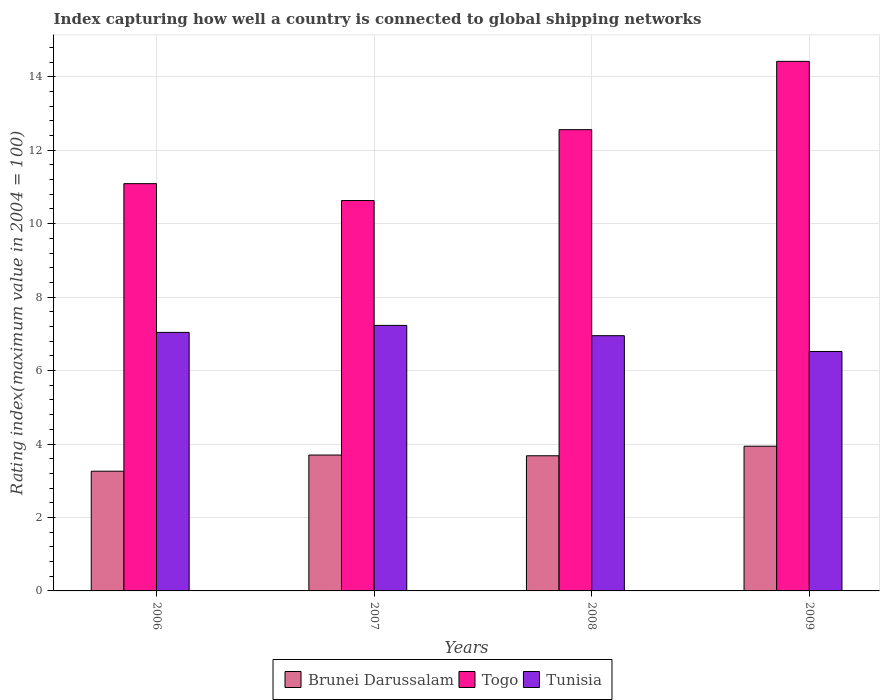How many different coloured bars are there?
Offer a terse response. 3. How many groups of bars are there?
Make the answer very short. 4. Are the number of bars per tick equal to the number of legend labels?
Give a very brief answer. Yes. Are the number of bars on each tick of the X-axis equal?
Give a very brief answer. Yes. What is the label of the 3rd group of bars from the left?
Provide a succinct answer. 2008. What is the rating index in Brunei Darussalam in 2006?
Offer a very short reply. 3.26. Across all years, what is the maximum rating index in Togo?
Ensure brevity in your answer.  14.42. Across all years, what is the minimum rating index in Tunisia?
Your response must be concise. 6.52. In which year was the rating index in Tunisia maximum?
Provide a short and direct response. 2007. In which year was the rating index in Tunisia minimum?
Provide a succinct answer. 2009. What is the total rating index in Tunisia in the graph?
Provide a short and direct response. 27.74. What is the difference between the rating index in Brunei Darussalam in 2008 and that in 2009?
Offer a terse response. -0.26. What is the difference between the rating index in Brunei Darussalam in 2008 and the rating index in Togo in 2007?
Provide a short and direct response. -6.95. What is the average rating index in Brunei Darussalam per year?
Ensure brevity in your answer.  3.65. In the year 2009, what is the difference between the rating index in Brunei Darussalam and rating index in Tunisia?
Offer a very short reply. -2.58. What is the ratio of the rating index in Tunisia in 2007 to that in 2008?
Offer a terse response. 1.04. Is the difference between the rating index in Brunei Darussalam in 2007 and 2009 greater than the difference between the rating index in Tunisia in 2007 and 2009?
Offer a very short reply. No. What is the difference between the highest and the second highest rating index in Tunisia?
Your response must be concise. 0.19. What is the difference between the highest and the lowest rating index in Tunisia?
Your answer should be compact. 0.71. In how many years, is the rating index in Brunei Darussalam greater than the average rating index in Brunei Darussalam taken over all years?
Give a very brief answer. 3. What does the 1st bar from the left in 2008 represents?
Provide a short and direct response. Brunei Darussalam. What does the 3rd bar from the right in 2008 represents?
Your response must be concise. Brunei Darussalam. Are all the bars in the graph horizontal?
Give a very brief answer. No. How many years are there in the graph?
Give a very brief answer. 4. What is the difference between two consecutive major ticks on the Y-axis?
Keep it short and to the point. 2. Are the values on the major ticks of Y-axis written in scientific E-notation?
Provide a succinct answer. No. Does the graph contain any zero values?
Provide a succinct answer. No. Does the graph contain grids?
Provide a short and direct response. Yes. Where does the legend appear in the graph?
Keep it short and to the point. Bottom center. How many legend labels are there?
Provide a short and direct response. 3. What is the title of the graph?
Provide a short and direct response. Index capturing how well a country is connected to global shipping networks. Does "Nigeria" appear as one of the legend labels in the graph?
Offer a very short reply. No. What is the label or title of the X-axis?
Your answer should be compact. Years. What is the label or title of the Y-axis?
Keep it short and to the point. Rating index(maximum value in 2004 = 100). What is the Rating index(maximum value in 2004 = 100) in Brunei Darussalam in 2006?
Make the answer very short. 3.26. What is the Rating index(maximum value in 2004 = 100) in Togo in 2006?
Keep it short and to the point. 11.09. What is the Rating index(maximum value in 2004 = 100) of Tunisia in 2006?
Offer a terse response. 7.04. What is the Rating index(maximum value in 2004 = 100) in Brunei Darussalam in 2007?
Your answer should be very brief. 3.7. What is the Rating index(maximum value in 2004 = 100) of Togo in 2007?
Offer a very short reply. 10.63. What is the Rating index(maximum value in 2004 = 100) in Tunisia in 2007?
Your response must be concise. 7.23. What is the Rating index(maximum value in 2004 = 100) of Brunei Darussalam in 2008?
Ensure brevity in your answer.  3.68. What is the Rating index(maximum value in 2004 = 100) in Togo in 2008?
Offer a very short reply. 12.56. What is the Rating index(maximum value in 2004 = 100) in Tunisia in 2008?
Provide a short and direct response. 6.95. What is the Rating index(maximum value in 2004 = 100) of Brunei Darussalam in 2009?
Make the answer very short. 3.94. What is the Rating index(maximum value in 2004 = 100) of Togo in 2009?
Offer a terse response. 14.42. What is the Rating index(maximum value in 2004 = 100) in Tunisia in 2009?
Give a very brief answer. 6.52. Across all years, what is the maximum Rating index(maximum value in 2004 = 100) in Brunei Darussalam?
Keep it short and to the point. 3.94. Across all years, what is the maximum Rating index(maximum value in 2004 = 100) of Togo?
Give a very brief answer. 14.42. Across all years, what is the maximum Rating index(maximum value in 2004 = 100) of Tunisia?
Keep it short and to the point. 7.23. Across all years, what is the minimum Rating index(maximum value in 2004 = 100) of Brunei Darussalam?
Provide a short and direct response. 3.26. Across all years, what is the minimum Rating index(maximum value in 2004 = 100) of Togo?
Make the answer very short. 10.63. Across all years, what is the minimum Rating index(maximum value in 2004 = 100) in Tunisia?
Make the answer very short. 6.52. What is the total Rating index(maximum value in 2004 = 100) in Brunei Darussalam in the graph?
Keep it short and to the point. 14.58. What is the total Rating index(maximum value in 2004 = 100) in Togo in the graph?
Offer a very short reply. 48.7. What is the total Rating index(maximum value in 2004 = 100) of Tunisia in the graph?
Give a very brief answer. 27.74. What is the difference between the Rating index(maximum value in 2004 = 100) in Brunei Darussalam in 2006 and that in 2007?
Offer a terse response. -0.44. What is the difference between the Rating index(maximum value in 2004 = 100) of Togo in 2006 and that in 2007?
Your answer should be very brief. 0.46. What is the difference between the Rating index(maximum value in 2004 = 100) of Tunisia in 2006 and that in 2007?
Provide a short and direct response. -0.19. What is the difference between the Rating index(maximum value in 2004 = 100) in Brunei Darussalam in 2006 and that in 2008?
Your response must be concise. -0.42. What is the difference between the Rating index(maximum value in 2004 = 100) in Togo in 2006 and that in 2008?
Your answer should be very brief. -1.47. What is the difference between the Rating index(maximum value in 2004 = 100) of Tunisia in 2006 and that in 2008?
Provide a succinct answer. 0.09. What is the difference between the Rating index(maximum value in 2004 = 100) in Brunei Darussalam in 2006 and that in 2009?
Provide a short and direct response. -0.68. What is the difference between the Rating index(maximum value in 2004 = 100) of Togo in 2006 and that in 2009?
Your answer should be very brief. -3.33. What is the difference between the Rating index(maximum value in 2004 = 100) in Tunisia in 2006 and that in 2009?
Offer a very short reply. 0.52. What is the difference between the Rating index(maximum value in 2004 = 100) in Brunei Darussalam in 2007 and that in 2008?
Provide a short and direct response. 0.02. What is the difference between the Rating index(maximum value in 2004 = 100) of Togo in 2007 and that in 2008?
Provide a short and direct response. -1.93. What is the difference between the Rating index(maximum value in 2004 = 100) of Tunisia in 2007 and that in 2008?
Offer a very short reply. 0.28. What is the difference between the Rating index(maximum value in 2004 = 100) of Brunei Darussalam in 2007 and that in 2009?
Give a very brief answer. -0.24. What is the difference between the Rating index(maximum value in 2004 = 100) of Togo in 2007 and that in 2009?
Provide a succinct answer. -3.79. What is the difference between the Rating index(maximum value in 2004 = 100) of Tunisia in 2007 and that in 2009?
Provide a short and direct response. 0.71. What is the difference between the Rating index(maximum value in 2004 = 100) in Brunei Darussalam in 2008 and that in 2009?
Ensure brevity in your answer.  -0.26. What is the difference between the Rating index(maximum value in 2004 = 100) of Togo in 2008 and that in 2009?
Your answer should be compact. -1.86. What is the difference between the Rating index(maximum value in 2004 = 100) in Tunisia in 2008 and that in 2009?
Make the answer very short. 0.43. What is the difference between the Rating index(maximum value in 2004 = 100) in Brunei Darussalam in 2006 and the Rating index(maximum value in 2004 = 100) in Togo in 2007?
Your answer should be compact. -7.37. What is the difference between the Rating index(maximum value in 2004 = 100) of Brunei Darussalam in 2006 and the Rating index(maximum value in 2004 = 100) of Tunisia in 2007?
Keep it short and to the point. -3.97. What is the difference between the Rating index(maximum value in 2004 = 100) of Togo in 2006 and the Rating index(maximum value in 2004 = 100) of Tunisia in 2007?
Provide a succinct answer. 3.86. What is the difference between the Rating index(maximum value in 2004 = 100) in Brunei Darussalam in 2006 and the Rating index(maximum value in 2004 = 100) in Togo in 2008?
Your answer should be very brief. -9.3. What is the difference between the Rating index(maximum value in 2004 = 100) in Brunei Darussalam in 2006 and the Rating index(maximum value in 2004 = 100) in Tunisia in 2008?
Provide a succinct answer. -3.69. What is the difference between the Rating index(maximum value in 2004 = 100) in Togo in 2006 and the Rating index(maximum value in 2004 = 100) in Tunisia in 2008?
Your answer should be compact. 4.14. What is the difference between the Rating index(maximum value in 2004 = 100) of Brunei Darussalam in 2006 and the Rating index(maximum value in 2004 = 100) of Togo in 2009?
Keep it short and to the point. -11.16. What is the difference between the Rating index(maximum value in 2004 = 100) of Brunei Darussalam in 2006 and the Rating index(maximum value in 2004 = 100) of Tunisia in 2009?
Provide a succinct answer. -3.26. What is the difference between the Rating index(maximum value in 2004 = 100) of Togo in 2006 and the Rating index(maximum value in 2004 = 100) of Tunisia in 2009?
Provide a short and direct response. 4.57. What is the difference between the Rating index(maximum value in 2004 = 100) in Brunei Darussalam in 2007 and the Rating index(maximum value in 2004 = 100) in Togo in 2008?
Your response must be concise. -8.86. What is the difference between the Rating index(maximum value in 2004 = 100) in Brunei Darussalam in 2007 and the Rating index(maximum value in 2004 = 100) in Tunisia in 2008?
Offer a terse response. -3.25. What is the difference between the Rating index(maximum value in 2004 = 100) of Togo in 2007 and the Rating index(maximum value in 2004 = 100) of Tunisia in 2008?
Your answer should be very brief. 3.68. What is the difference between the Rating index(maximum value in 2004 = 100) in Brunei Darussalam in 2007 and the Rating index(maximum value in 2004 = 100) in Togo in 2009?
Ensure brevity in your answer.  -10.72. What is the difference between the Rating index(maximum value in 2004 = 100) in Brunei Darussalam in 2007 and the Rating index(maximum value in 2004 = 100) in Tunisia in 2009?
Keep it short and to the point. -2.82. What is the difference between the Rating index(maximum value in 2004 = 100) of Togo in 2007 and the Rating index(maximum value in 2004 = 100) of Tunisia in 2009?
Give a very brief answer. 4.11. What is the difference between the Rating index(maximum value in 2004 = 100) in Brunei Darussalam in 2008 and the Rating index(maximum value in 2004 = 100) in Togo in 2009?
Provide a succinct answer. -10.74. What is the difference between the Rating index(maximum value in 2004 = 100) in Brunei Darussalam in 2008 and the Rating index(maximum value in 2004 = 100) in Tunisia in 2009?
Offer a very short reply. -2.84. What is the difference between the Rating index(maximum value in 2004 = 100) in Togo in 2008 and the Rating index(maximum value in 2004 = 100) in Tunisia in 2009?
Your answer should be compact. 6.04. What is the average Rating index(maximum value in 2004 = 100) in Brunei Darussalam per year?
Give a very brief answer. 3.65. What is the average Rating index(maximum value in 2004 = 100) of Togo per year?
Give a very brief answer. 12.18. What is the average Rating index(maximum value in 2004 = 100) in Tunisia per year?
Provide a succinct answer. 6.93. In the year 2006, what is the difference between the Rating index(maximum value in 2004 = 100) of Brunei Darussalam and Rating index(maximum value in 2004 = 100) of Togo?
Your response must be concise. -7.83. In the year 2006, what is the difference between the Rating index(maximum value in 2004 = 100) of Brunei Darussalam and Rating index(maximum value in 2004 = 100) of Tunisia?
Your answer should be very brief. -3.78. In the year 2006, what is the difference between the Rating index(maximum value in 2004 = 100) of Togo and Rating index(maximum value in 2004 = 100) of Tunisia?
Your response must be concise. 4.05. In the year 2007, what is the difference between the Rating index(maximum value in 2004 = 100) in Brunei Darussalam and Rating index(maximum value in 2004 = 100) in Togo?
Offer a very short reply. -6.93. In the year 2007, what is the difference between the Rating index(maximum value in 2004 = 100) in Brunei Darussalam and Rating index(maximum value in 2004 = 100) in Tunisia?
Offer a very short reply. -3.53. In the year 2007, what is the difference between the Rating index(maximum value in 2004 = 100) of Togo and Rating index(maximum value in 2004 = 100) of Tunisia?
Offer a very short reply. 3.4. In the year 2008, what is the difference between the Rating index(maximum value in 2004 = 100) of Brunei Darussalam and Rating index(maximum value in 2004 = 100) of Togo?
Provide a short and direct response. -8.88. In the year 2008, what is the difference between the Rating index(maximum value in 2004 = 100) in Brunei Darussalam and Rating index(maximum value in 2004 = 100) in Tunisia?
Make the answer very short. -3.27. In the year 2008, what is the difference between the Rating index(maximum value in 2004 = 100) in Togo and Rating index(maximum value in 2004 = 100) in Tunisia?
Your answer should be compact. 5.61. In the year 2009, what is the difference between the Rating index(maximum value in 2004 = 100) of Brunei Darussalam and Rating index(maximum value in 2004 = 100) of Togo?
Ensure brevity in your answer.  -10.48. In the year 2009, what is the difference between the Rating index(maximum value in 2004 = 100) in Brunei Darussalam and Rating index(maximum value in 2004 = 100) in Tunisia?
Provide a short and direct response. -2.58. What is the ratio of the Rating index(maximum value in 2004 = 100) of Brunei Darussalam in 2006 to that in 2007?
Your answer should be compact. 0.88. What is the ratio of the Rating index(maximum value in 2004 = 100) in Togo in 2006 to that in 2007?
Ensure brevity in your answer.  1.04. What is the ratio of the Rating index(maximum value in 2004 = 100) of Tunisia in 2006 to that in 2007?
Make the answer very short. 0.97. What is the ratio of the Rating index(maximum value in 2004 = 100) of Brunei Darussalam in 2006 to that in 2008?
Your answer should be very brief. 0.89. What is the ratio of the Rating index(maximum value in 2004 = 100) of Togo in 2006 to that in 2008?
Provide a short and direct response. 0.88. What is the ratio of the Rating index(maximum value in 2004 = 100) of Tunisia in 2006 to that in 2008?
Your answer should be very brief. 1.01. What is the ratio of the Rating index(maximum value in 2004 = 100) of Brunei Darussalam in 2006 to that in 2009?
Provide a short and direct response. 0.83. What is the ratio of the Rating index(maximum value in 2004 = 100) of Togo in 2006 to that in 2009?
Offer a very short reply. 0.77. What is the ratio of the Rating index(maximum value in 2004 = 100) of Tunisia in 2006 to that in 2009?
Your answer should be very brief. 1.08. What is the ratio of the Rating index(maximum value in 2004 = 100) in Brunei Darussalam in 2007 to that in 2008?
Provide a succinct answer. 1.01. What is the ratio of the Rating index(maximum value in 2004 = 100) of Togo in 2007 to that in 2008?
Offer a terse response. 0.85. What is the ratio of the Rating index(maximum value in 2004 = 100) in Tunisia in 2007 to that in 2008?
Keep it short and to the point. 1.04. What is the ratio of the Rating index(maximum value in 2004 = 100) of Brunei Darussalam in 2007 to that in 2009?
Provide a short and direct response. 0.94. What is the ratio of the Rating index(maximum value in 2004 = 100) of Togo in 2007 to that in 2009?
Your answer should be compact. 0.74. What is the ratio of the Rating index(maximum value in 2004 = 100) in Tunisia in 2007 to that in 2009?
Offer a terse response. 1.11. What is the ratio of the Rating index(maximum value in 2004 = 100) of Brunei Darussalam in 2008 to that in 2009?
Your response must be concise. 0.93. What is the ratio of the Rating index(maximum value in 2004 = 100) in Togo in 2008 to that in 2009?
Your answer should be very brief. 0.87. What is the ratio of the Rating index(maximum value in 2004 = 100) in Tunisia in 2008 to that in 2009?
Offer a terse response. 1.07. What is the difference between the highest and the second highest Rating index(maximum value in 2004 = 100) in Brunei Darussalam?
Your answer should be compact. 0.24. What is the difference between the highest and the second highest Rating index(maximum value in 2004 = 100) in Togo?
Your answer should be compact. 1.86. What is the difference between the highest and the second highest Rating index(maximum value in 2004 = 100) of Tunisia?
Keep it short and to the point. 0.19. What is the difference between the highest and the lowest Rating index(maximum value in 2004 = 100) of Brunei Darussalam?
Your response must be concise. 0.68. What is the difference between the highest and the lowest Rating index(maximum value in 2004 = 100) of Togo?
Provide a succinct answer. 3.79. What is the difference between the highest and the lowest Rating index(maximum value in 2004 = 100) in Tunisia?
Keep it short and to the point. 0.71. 